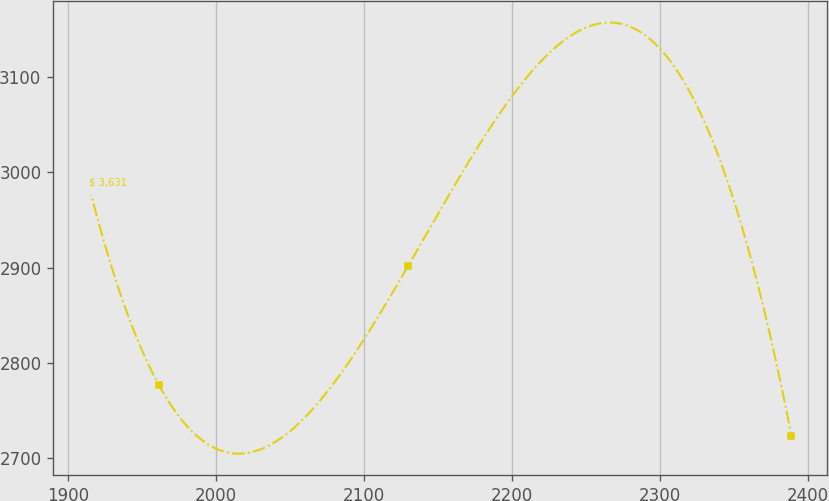Convert chart to OTSL. <chart><loc_0><loc_0><loc_500><loc_500><line_chart><ecel><fcel>$ 3,631<nl><fcel>1913.75<fcel>2988.63<nl><fcel>1961.28<fcel>2777.26<nl><fcel>2129.75<fcel>2901.17<nl><fcel>2389<fcel>2723.76<nl></chart> 